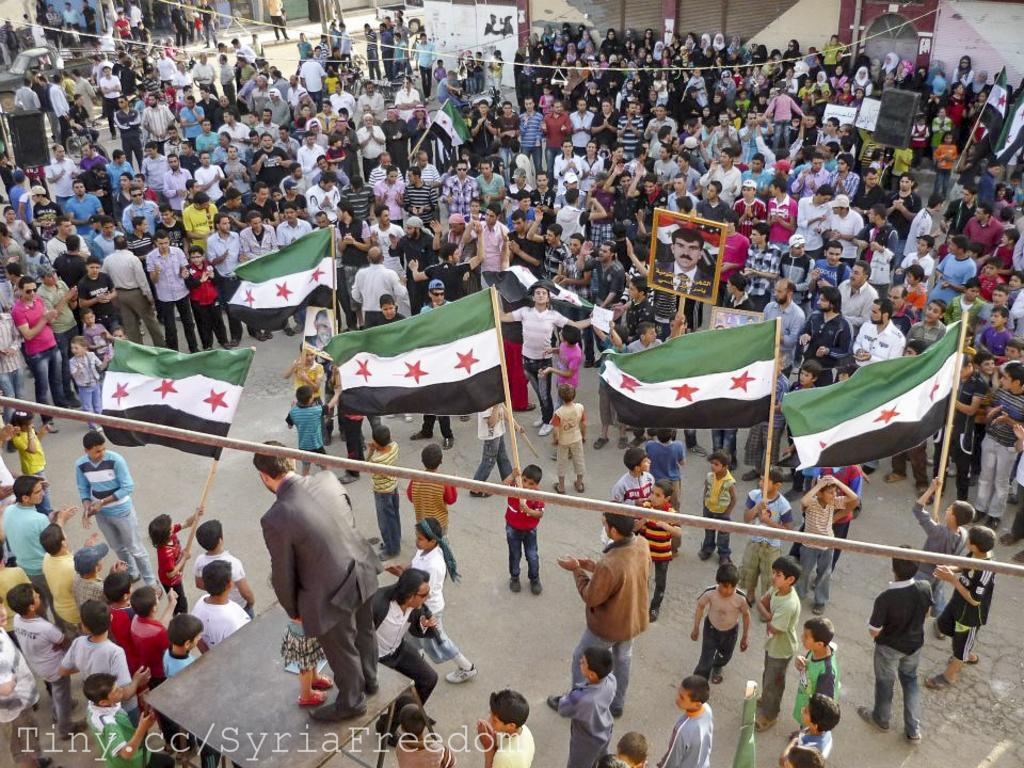What are the people in the image doing? There is a group of people standing on the road in the image. What can be seen in the image besides the people? There are flags, speakers, frames, a table, vehicles, and banners in the image. Can you describe the objects that are used for displaying or amplifying information? There are flags and speakers in the image. What type of furniture is present in the image? There is a table in the image. What can be seen in the background of the image? There are vehicles and banners in the background of the image. How many birds are sitting on the table in the image? There are no birds present on the table or in the image. What type of egg is being used as a decoration on the banners in the image? There are no eggs present on the banners or in the image. 